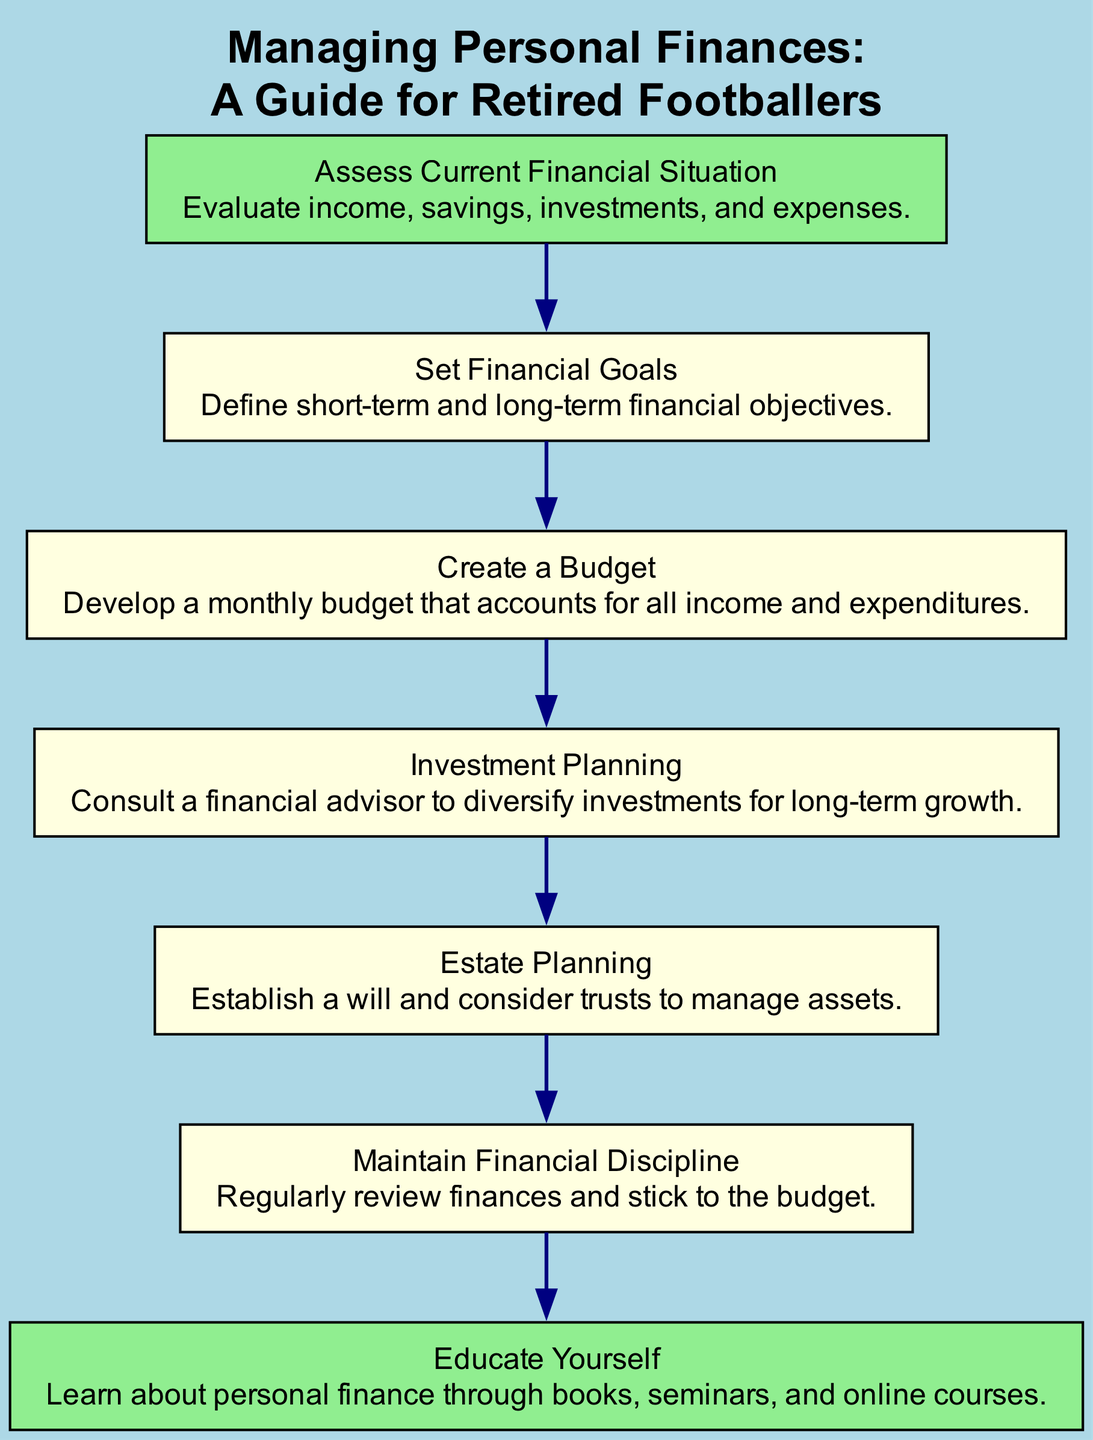What is the first step in managing personal finances? The first node in the diagram is "Assess Current Financial Situation," indicating this is the initial step to evaluate one's financial status.
Answer: Assess Current Financial Situation How many nodes are present in the diagram? There are seven nodes listed in the data provided, representing different steps in managing personal finances.
Answer: 7 Which step follows "Create a Budget"? The step that follows "Create a Budget" is "Investment Planning," indicating the order of actions in managing finances.
Answer: Investment Planning What is the last step listed in the flow chart? The final node in the diagram is "Maintain Financial Discipline," signifying it is the concluding step in the financial management process.
Answer: Maintain Financial Discipline How many edges connect the steps in the diagram? Each step in the diagram is connected to the next, creating a linear flow. With seven nodes, there will be six edges between them.
Answer: 6 What action is suggested after "Set Financial Goals"? The action that comes after "Set Financial Goals" is "Create a Budget," which implies the progression from defining goals to planning finances accordingly.
Answer: Create a Budget How are the nodes styled visually in the diagram? The diagram uses light yellow rectangles for the nodes, and the first and last nodes are highlighted in light green to differentiate them from the intermediate steps.
Answer: Light yellow with green highlights What knowledge source is recommended in the flow chart? The flow chart advises to "Educate Yourself," indicating that gaining knowledge through various means is vital for personal financial management.
Answer: Educate Yourself What should be established during "Estate Planning"? During "Estate Planning," one should establish a will and consider trusts to effectively manage assets.
Answer: A will and trusts 